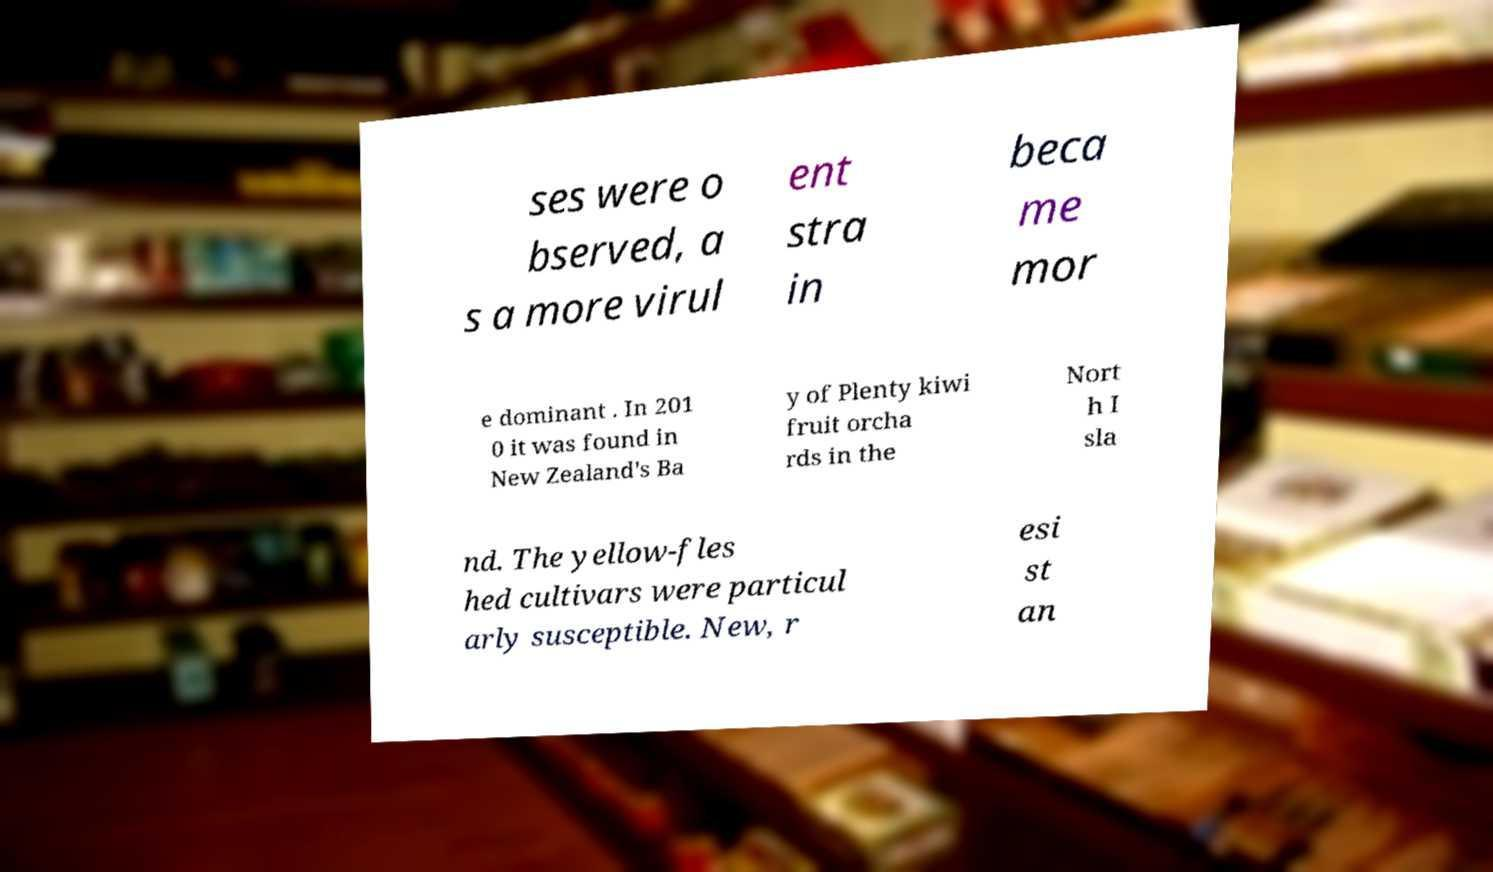Can you accurately transcribe the text from the provided image for me? ses were o bserved, a s a more virul ent stra in beca me mor e dominant . In 201 0 it was found in New Zealand's Ba y of Plenty kiwi fruit orcha rds in the Nort h I sla nd. The yellow-fles hed cultivars were particul arly susceptible. New, r esi st an 